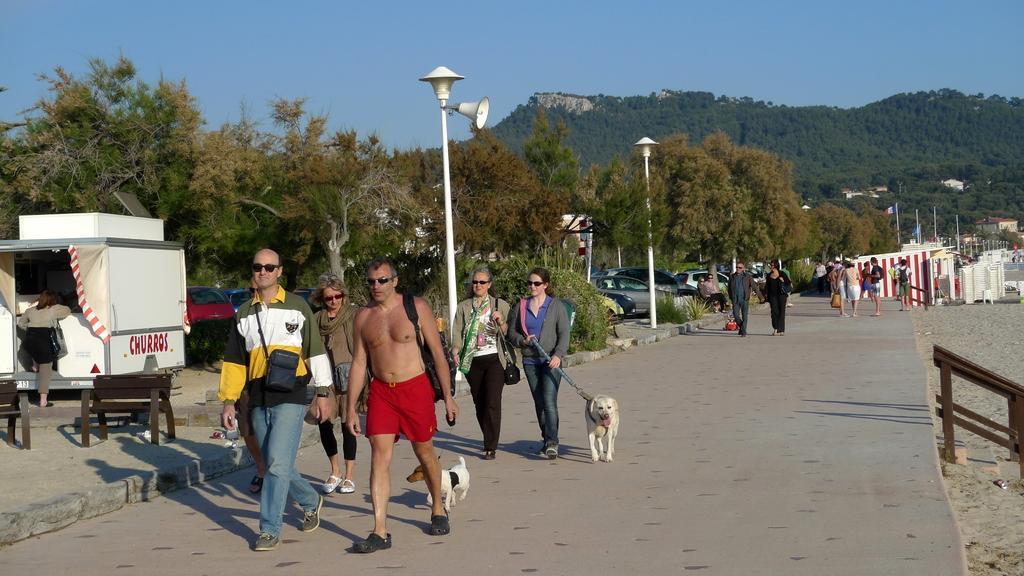Describe this image in one or two sentences. In the center of the image we can see some persons are walking, some of them are carrying dog and bag. In the background of the image we can see cars, truck, lamp, poles, trees and some persons, wall, hills are there. At the bottom of the image there is a road. At the top of the image there is a sky. On the left side of the image we can see benches are there. 